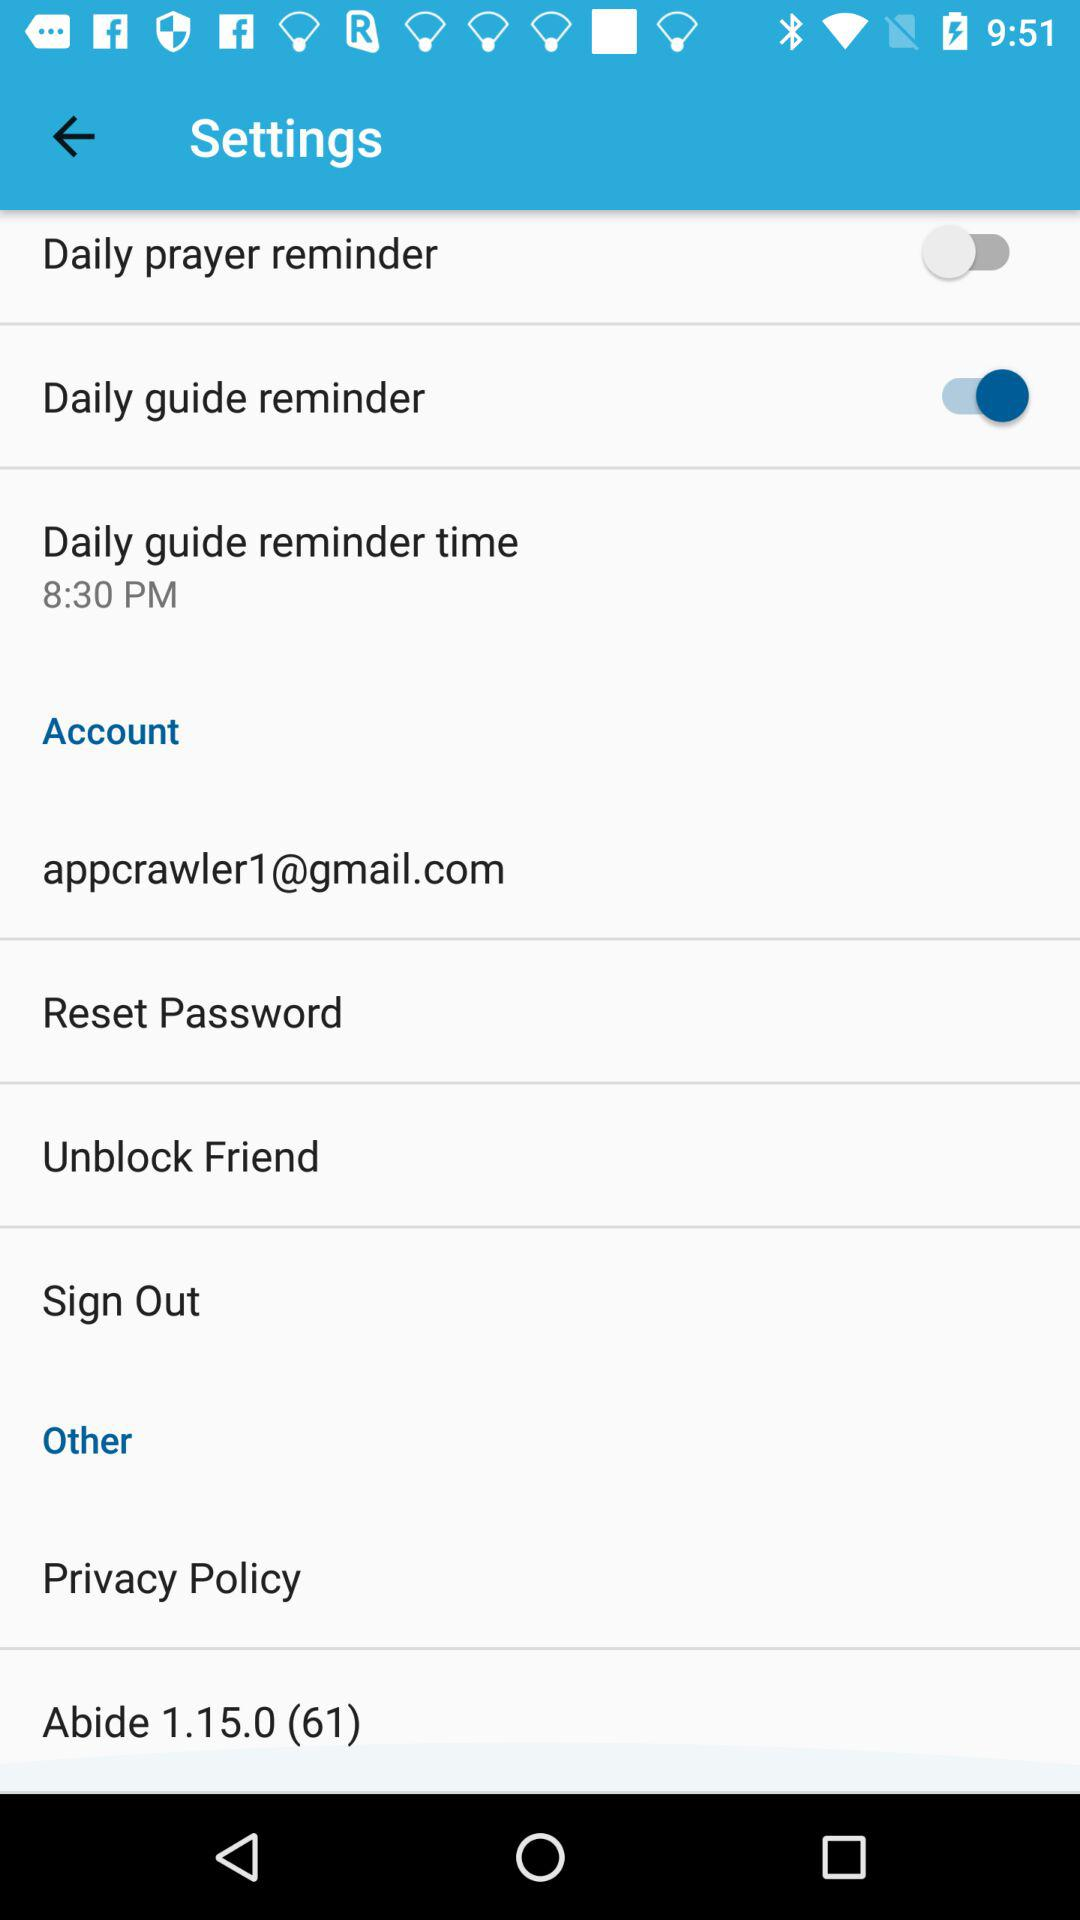What is the email address? The email address is appcrawler1@gmail.com. 